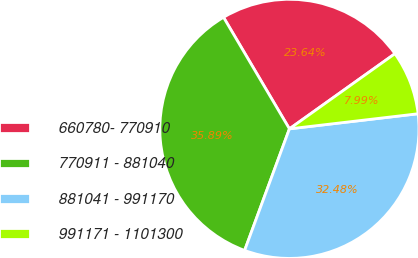Convert chart. <chart><loc_0><loc_0><loc_500><loc_500><pie_chart><fcel>660780- 770910<fcel>770911 - 881040<fcel>881041 - 991170<fcel>991171 - 1101300<nl><fcel>23.64%<fcel>35.89%<fcel>32.48%<fcel>7.99%<nl></chart> 